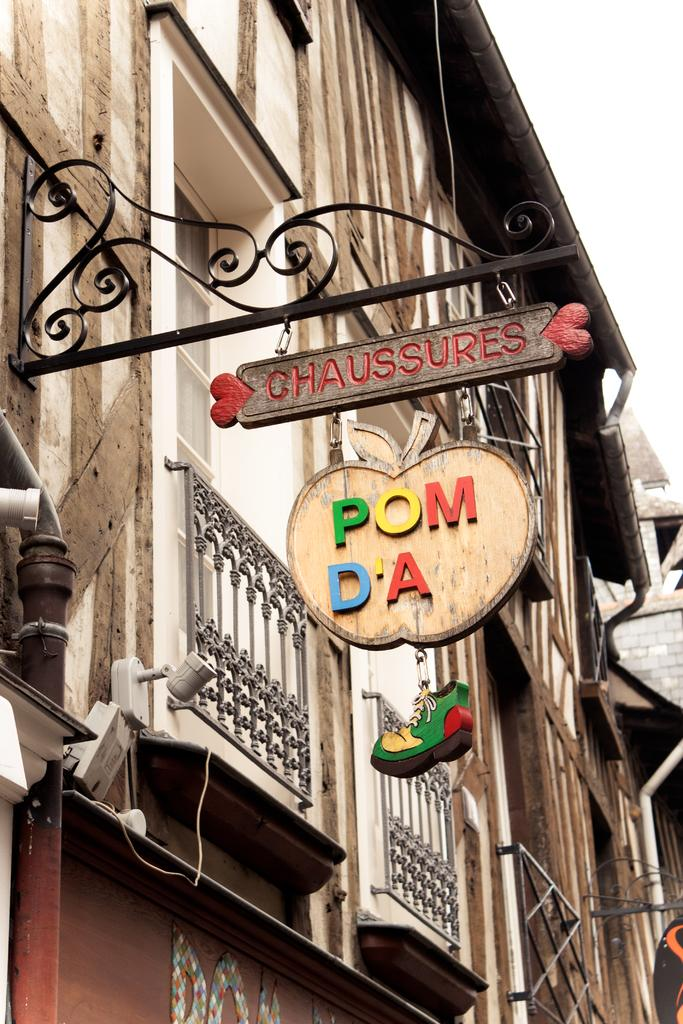<image>
Create a compact narrative representing the image presented. A building displays a sign that says chaussures in red paint on the top. 